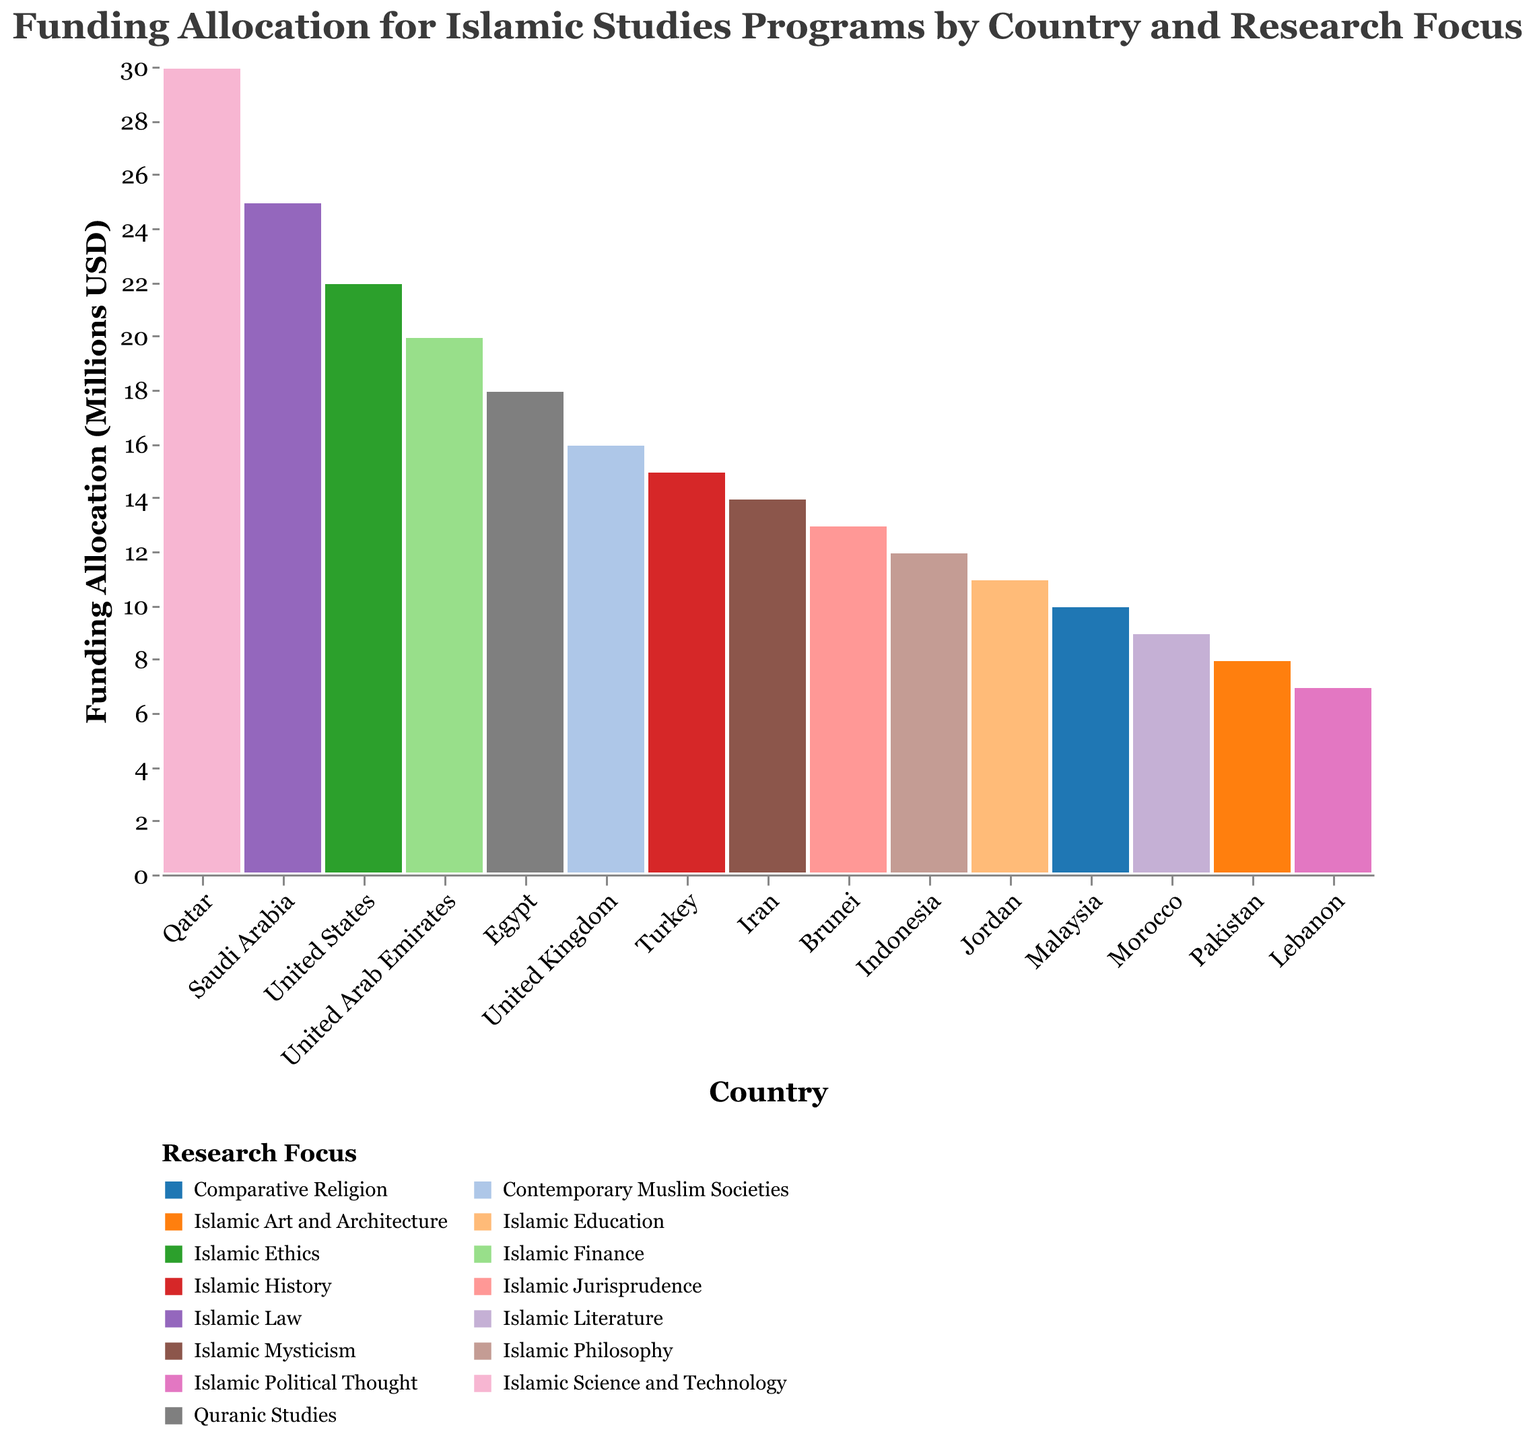What is the total funding allocation for Islamic studies programs in Qatar? Referring to the figure, the raw value displayed for Qatar's funding allocation is 30 million USD.
Answer: 30 million USD Which country has the highest funding allocation for Islamic studies, and what's the research focus? According to the figure, Qatar has the highest funding allocation with a focus on Islamic Science and Technology.
Answer: Qatar, Islamic Science and Technology How much more funding does Saudi Arabia allocate to Islamic studies compared to Egypt? Saudi Arabia allocates 25 million USD, and Egypt allocates 18 million USD. The difference is 25 - 18 = 7 million USD.
Answer: 7 million USD Which research focus in the United States has received funding, and how much? The United States has allocated 22 million USD to research focused on Islamic Ethics.
Answer: Islamic Ethics, 22 million USD Among the countries listed, which one has the lowest funding allocation for Islamic studies and what is the research focus? Lebanon has the lowest funding allocation with 7 million USD focused on Islamic Political Thought.
Answer: Lebanon, Islamic Political Thought What are the three countries with the highest funding allocations for Islamic studies? Qatar (30 million USD), Saudi Arabia (25 million USD), and the United States (22 million USD) have the highest funding allocations.
Answer: Qatar, Saudi Arabia, United States Which research focus receives funding in both Malaysia and Brunei? In Malaysia, the focus is on Comparative Religion, whereas in Brunei it is on Islamic Jurisprudence. There is no common research focus between these two countries.
Answer: None How much more is the funding allocation for Islamic Finance in the United Arab Emirates compared to Islamic Mysticism in Iran? Funding for Islamic Finance in the UAE is 20 million USD, while for Islamic Mysticism in Iran is 14 million USD. The difference is 20 - 14 = 6 million USD.
Answer: 6 million USD Which two countries allocate funding for research focused on Islamic Law or Islamic Jurisprudence? Saudi Arabia allocates funding for Islamic Law, and Brunei allocates funding for Islamic Jurisprudence.
Answer: Saudi Arabia, Brunei What percentage of the total funding is allocated to Islamic Science and Technology in Qatar? The total funding allocation sums up to 240 million USD. Qatar's allocation is 30 million USD. The percentage is (30/240) * 100 = 12.5%.
Answer: 12.5% 